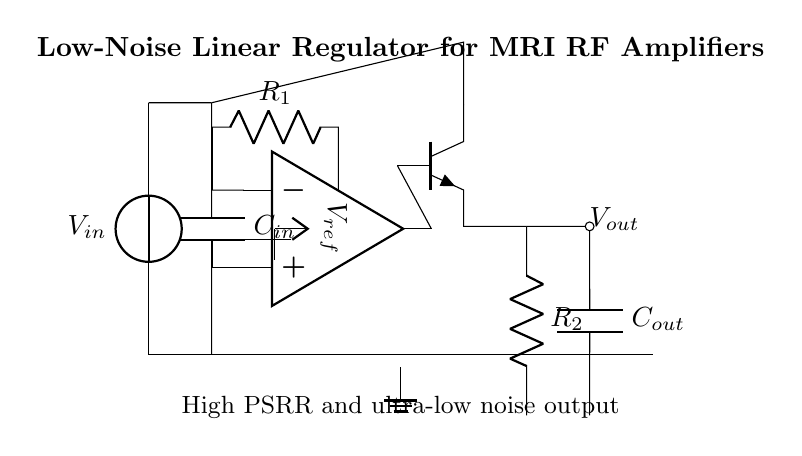What is the input voltage of this regulator? The input voltage is indicated as V_in, which is the voltage source at the top of the circuit diagram.
Answer: V_in What component is used for voltage reference? The voltage reference is provided by the component labeled V_ref, which is represented as a voltage source in the diagram.
Answer: V_ref What is the purpose of capacitor C_out? The capacitor C_out is used to filter the output voltage, providing stability and reducing noise in the output, which is vital for sensitive RF amplifier circuits.
Answer: Filter and stabilize output How is the error amplifier connected in this circuit? The error amplifier's non-inverting input is connected to the voltage reference, and its output connects to the base of the pass transistor, forming a feedback loop to regulate the output voltage.
Answer: Feedback loop to pass transistor What is the output voltage of this regulator? The output voltage is indicated as V_out, which is the voltage available at the output node of the regulator circuit.
Answer: V_out What type of pass element is used in this regulator circuit? The pass element in this circuit is an NPN transistor, labeled as q1, which controls the output voltage based on the feedback from the error amplifier.
Answer: NPN transistor What is the expected outcome of having high PSRR in this circuit? High PSRR (Power Supply Rejection Ratio) means that the regulator efficiently maintains a stable output voltage despite fluctuations in the input voltage, crucial for maintaining low noise in RF amplifier circuits.
Answer: Stable output voltage 